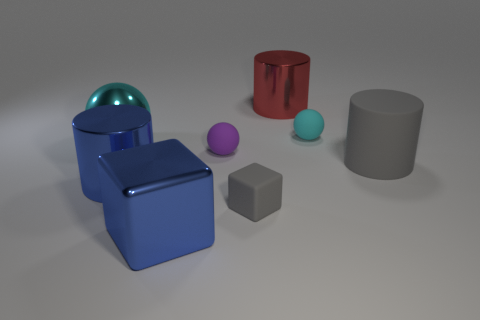What number of other objects are the same size as the gray rubber cylinder?
Give a very brief answer. 4. What is the shape of the object to the right of the cyan ball to the right of the small rubber thing that is on the left side of the tiny gray object?
Give a very brief answer. Cylinder. What shape is the big object that is on the right side of the small gray object and behind the big rubber cylinder?
Your answer should be compact. Cylinder. What number of things are either gray cylinders or big shiny cylinders that are behind the blue metallic cylinder?
Offer a very short reply. 2. Do the gray block and the big red cylinder have the same material?
Your response must be concise. No. How many other objects are the same shape as the red metal thing?
Offer a very short reply. 2. There is a metallic object that is both behind the large gray cylinder and to the left of the small purple rubber object; what size is it?
Provide a succinct answer. Large. How many metal objects are either yellow objects or large balls?
Provide a short and direct response. 1. Do the tiny object behind the purple sphere and the cyan object to the left of the blue metallic block have the same shape?
Your answer should be very brief. Yes. Are there any other cylinders that have the same material as the large red cylinder?
Make the answer very short. Yes. 